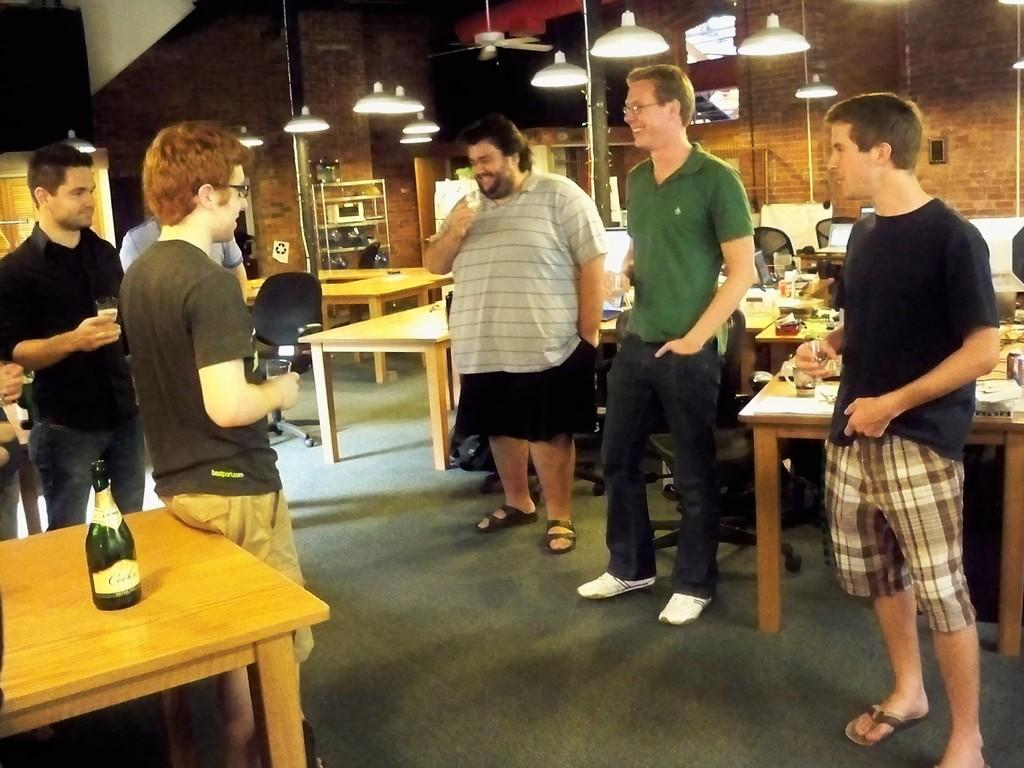What are the men in the image doing? The men in the image are standing near a table and smiling. What objects can be seen on the table? There are bottles and glasses on the table. What is the condition of the floor in the image? The image shows a floor. What can be seen at the top of the image? There are lights visible at the top of the image. What type of rhythm can be heard coming from the farm in the image? There is no farm or rhythm present in the image; it shows men standing near a table with bottles and glasses. How does the comparison between the two men in the image differ from the other two men? There is no comparison between the men in the image, as there are no distinguishing features mentioned in the provided facts. 